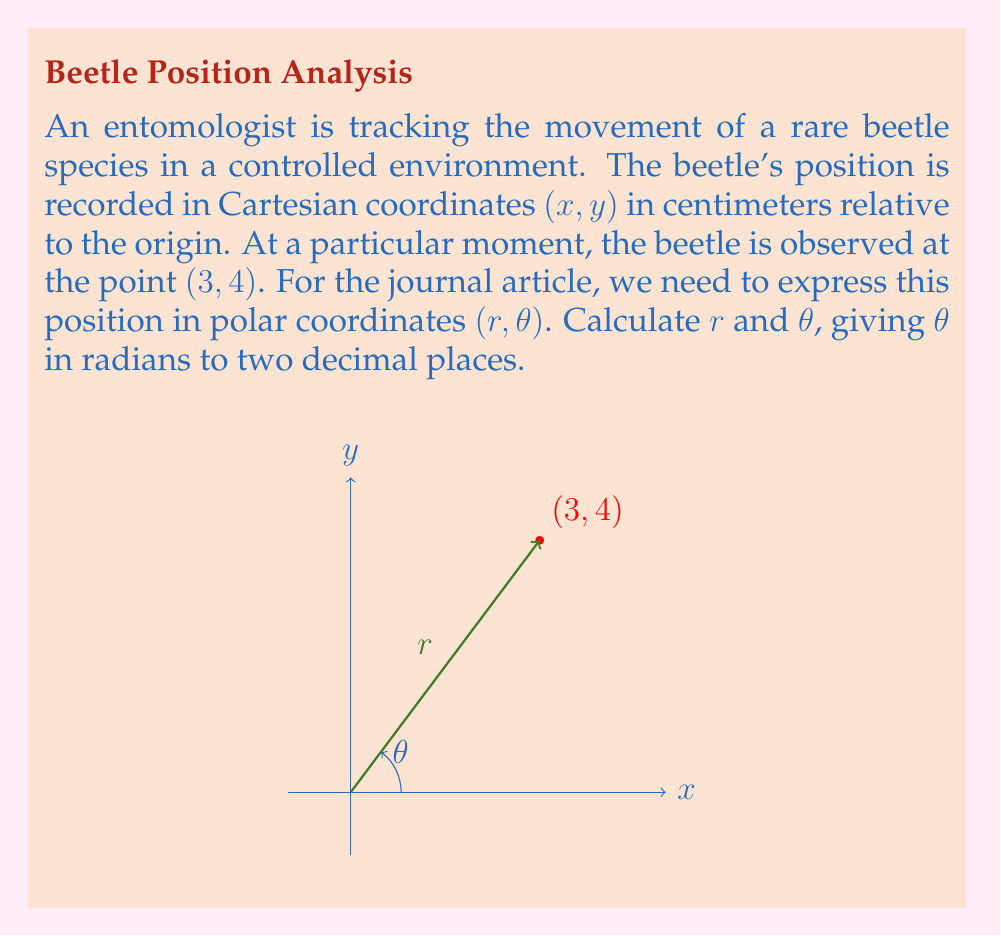Solve this math problem. To convert from Cartesian coordinates (x, y) to polar coordinates (r, θ), we use the following formulas:

1. For r (the distance from the origin):
   $$r = \sqrt{x^2 + y^2}$$

2. For θ (the angle from the positive x-axis):
   $$\theta = \tan^{-1}\left(\frac{y}{x}\right)$$

Step 1: Calculate r
$$r = \sqrt{3^2 + 4^2} = \sqrt{9 + 16} = \sqrt{25} = 5$$

Step 2: Calculate θ
$$\theta = \tan^{-1}\left(\frac{4}{3}\right) \approx 0.9272952180$$

Step 3: Round θ to two decimal places
$$\theta \approx 0.93\text{ radians}$$

Therefore, the polar coordinates are (5, 0.93).
Answer: $(5, 0.93)$ 